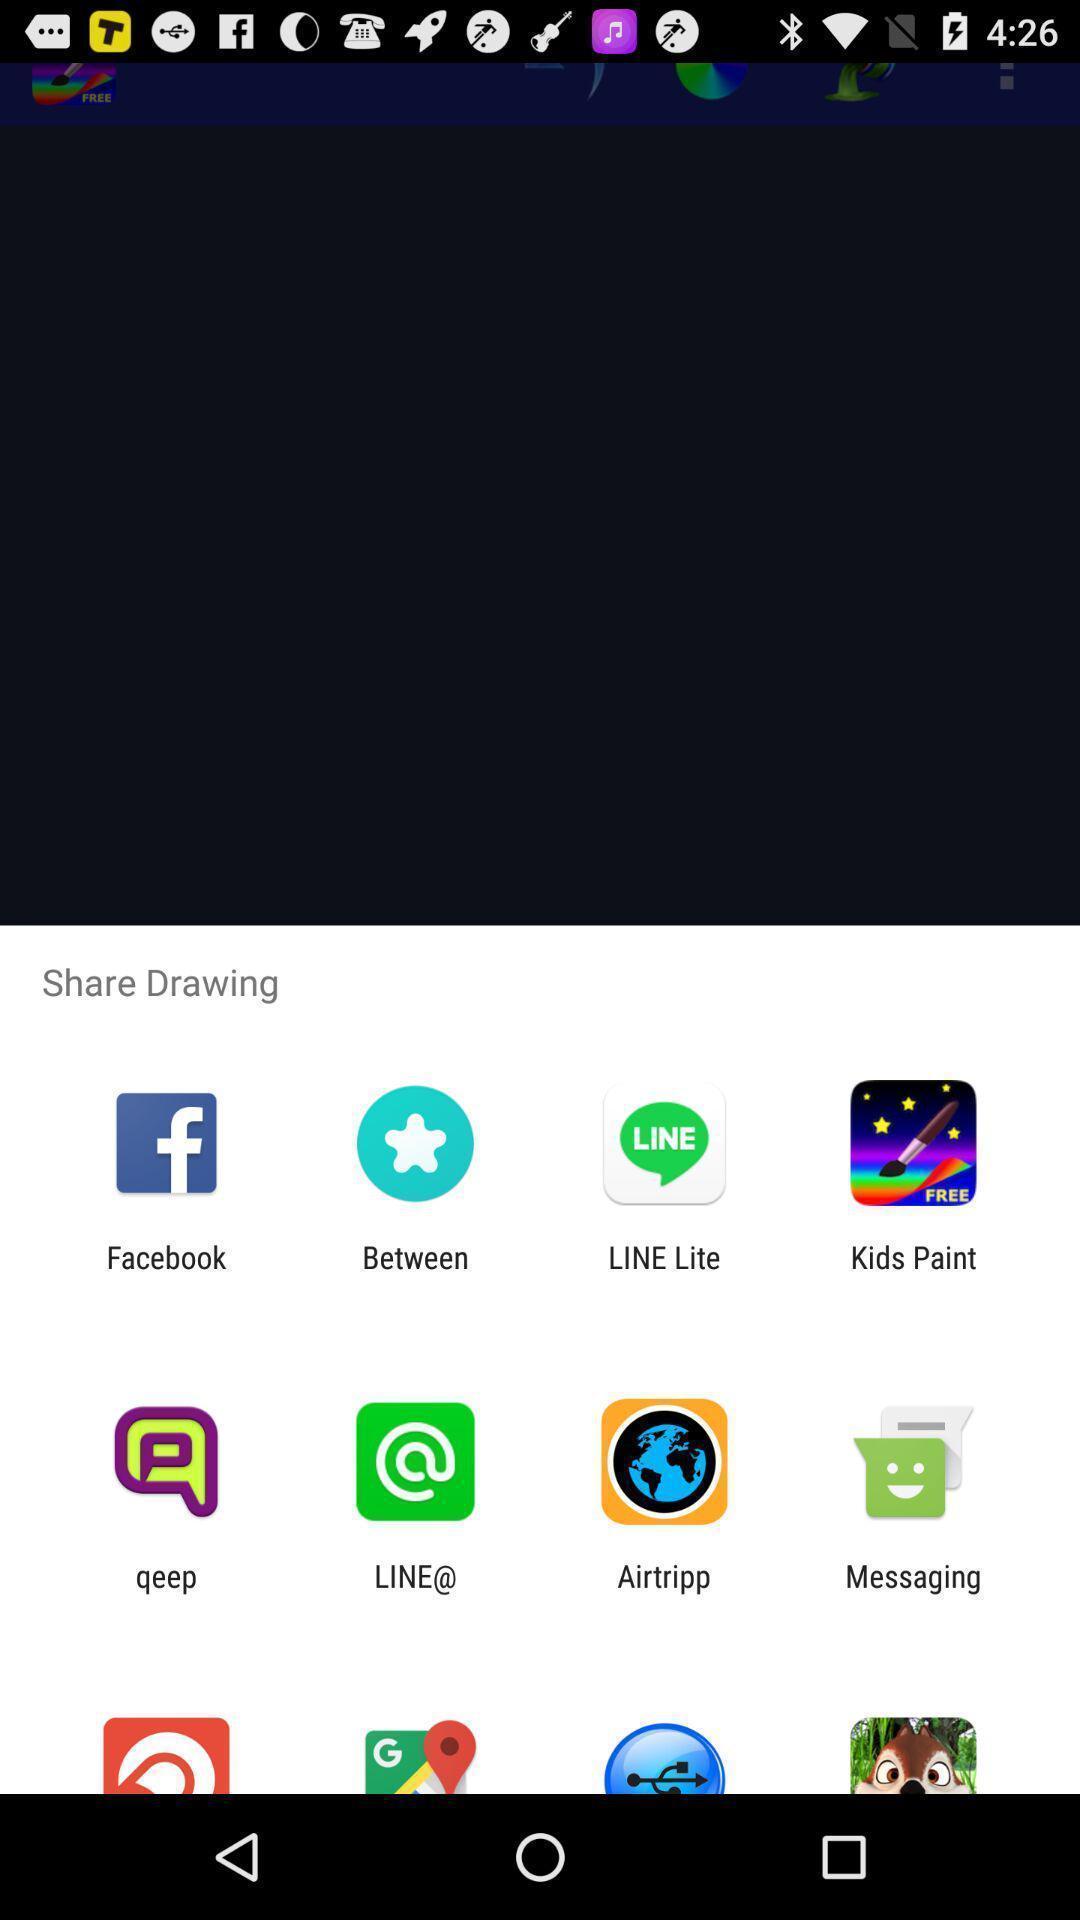Give me a narrative description of this picture. Push up message with multiple sharing options. 